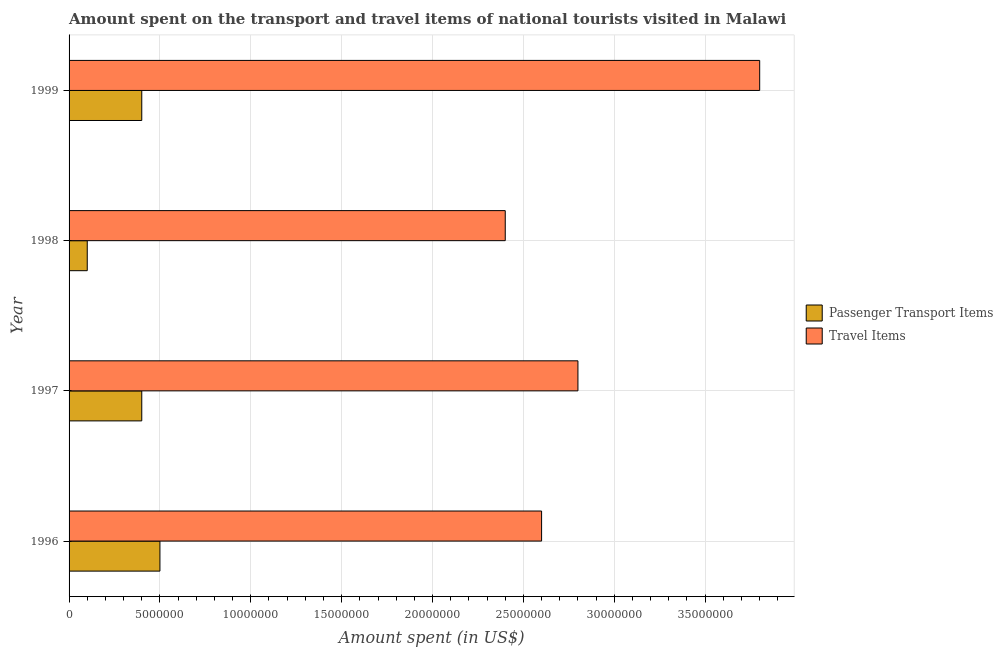Are the number of bars per tick equal to the number of legend labels?
Give a very brief answer. Yes. Are the number of bars on each tick of the Y-axis equal?
Give a very brief answer. Yes. How many bars are there on the 1st tick from the top?
Offer a very short reply. 2. How many bars are there on the 4th tick from the bottom?
Provide a succinct answer. 2. What is the label of the 4th group of bars from the top?
Provide a succinct answer. 1996. In how many cases, is the number of bars for a given year not equal to the number of legend labels?
Ensure brevity in your answer.  0. What is the amount spent on passenger transport items in 1998?
Your response must be concise. 1.00e+06. Across all years, what is the maximum amount spent in travel items?
Provide a short and direct response. 3.80e+07. Across all years, what is the minimum amount spent in travel items?
Make the answer very short. 2.40e+07. What is the total amount spent on passenger transport items in the graph?
Offer a terse response. 1.40e+07. What is the difference between the amount spent on passenger transport items in 1996 and that in 1999?
Offer a very short reply. 1.00e+06. What is the difference between the amount spent on passenger transport items in 1999 and the amount spent in travel items in 1996?
Make the answer very short. -2.20e+07. What is the average amount spent in travel items per year?
Provide a succinct answer. 2.90e+07. In the year 1999, what is the difference between the amount spent in travel items and amount spent on passenger transport items?
Provide a short and direct response. 3.40e+07. In how many years, is the amount spent in travel items greater than 31000000 US$?
Give a very brief answer. 1. What is the ratio of the amount spent in travel items in 1996 to that in 1998?
Offer a terse response. 1.08. Is the amount spent in travel items in 1996 less than that in 1998?
Provide a succinct answer. No. Is the difference between the amount spent in travel items in 1996 and 1998 greater than the difference between the amount spent on passenger transport items in 1996 and 1998?
Ensure brevity in your answer.  No. What is the difference between the highest and the second highest amount spent on passenger transport items?
Provide a succinct answer. 1.00e+06. What is the difference between the highest and the lowest amount spent in travel items?
Provide a short and direct response. 1.40e+07. In how many years, is the amount spent in travel items greater than the average amount spent in travel items taken over all years?
Ensure brevity in your answer.  1. Is the sum of the amount spent in travel items in 1998 and 1999 greater than the maximum amount spent on passenger transport items across all years?
Ensure brevity in your answer.  Yes. What does the 1st bar from the top in 1996 represents?
Give a very brief answer. Travel Items. What does the 1st bar from the bottom in 1997 represents?
Give a very brief answer. Passenger Transport Items. Are all the bars in the graph horizontal?
Make the answer very short. Yes. How many years are there in the graph?
Your answer should be compact. 4. Are the values on the major ticks of X-axis written in scientific E-notation?
Offer a very short reply. No. Does the graph contain any zero values?
Give a very brief answer. No. What is the title of the graph?
Your answer should be very brief. Amount spent on the transport and travel items of national tourists visited in Malawi. Does "Males" appear as one of the legend labels in the graph?
Offer a very short reply. No. What is the label or title of the X-axis?
Ensure brevity in your answer.  Amount spent (in US$). What is the Amount spent (in US$) of Passenger Transport Items in 1996?
Offer a terse response. 5.00e+06. What is the Amount spent (in US$) of Travel Items in 1996?
Your answer should be very brief. 2.60e+07. What is the Amount spent (in US$) of Travel Items in 1997?
Your answer should be compact. 2.80e+07. What is the Amount spent (in US$) in Travel Items in 1998?
Offer a terse response. 2.40e+07. What is the Amount spent (in US$) in Passenger Transport Items in 1999?
Ensure brevity in your answer.  4.00e+06. What is the Amount spent (in US$) in Travel Items in 1999?
Your response must be concise. 3.80e+07. Across all years, what is the maximum Amount spent (in US$) in Passenger Transport Items?
Your answer should be very brief. 5.00e+06. Across all years, what is the maximum Amount spent (in US$) in Travel Items?
Keep it short and to the point. 3.80e+07. Across all years, what is the minimum Amount spent (in US$) of Passenger Transport Items?
Provide a short and direct response. 1.00e+06. Across all years, what is the minimum Amount spent (in US$) in Travel Items?
Keep it short and to the point. 2.40e+07. What is the total Amount spent (in US$) in Passenger Transport Items in the graph?
Offer a very short reply. 1.40e+07. What is the total Amount spent (in US$) in Travel Items in the graph?
Keep it short and to the point. 1.16e+08. What is the difference between the Amount spent (in US$) in Passenger Transport Items in 1996 and that in 1999?
Your response must be concise. 1.00e+06. What is the difference between the Amount spent (in US$) in Travel Items in 1996 and that in 1999?
Provide a short and direct response. -1.20e+07. What is the difference between the Amount spent (in US$) in Passenger Transport Items in 1997 and that in 1998?
Your response must be concise. 3.00e+06. What is the difference between the Amount spent (in US$) in Travel Items in 1997 and that in 1998?
Ensure brevity in your answer.  4.00e+06. What is the difference between the Amount spent (in US$) in Passenger Transport Items in 1997 and that in 1999?
Offer a very short reply. 0. What is the difference between the Amount spent (in US$) of Travel Items in 1997 and that in 1999?
Your answer should be very brief. -1.00e+07. What is the difference between the Amount spent (in US$) of Passenger Transport Items in 1998 and that in 1999?
Your answer should be very brief. -3.00e+06. What is the difference between the Amount spent (in US$) in Travel Items in 1998 and that in 1999?
Ensure brevity in your answer.  -1.40e+07. What is the difference between the Amount spent (in US$) of Passenger Transport Items in 1996 and the Amount spent (in US$) of Travel Items in 1997?
Ensure brevity in your answer.  -2.30e+07. What is the difference between the Amount spent (in US$) in Passenger Transport Items in 1996 and the Amount spent (in US$) in Travel Items in 1998?
Provide a short and direct response. -1.90e+07. What is the difference between the Amount spent (in US$) in Passenger Transport Items in 1996 and the Amount spent (in US$) in Travel Items in 1999?
Make the answer very short. -3.30e+07. What is the difference between the Amount spent (in US$) in Passenger Transport Items in 1997 and the Amount spent (in US$) in Travel Items in 1998?
Provide a succinct answer. -2.00e+07. What is the difference between the Amount spent (in US$) in Passenger Transport Items in 1997 and the Amount spent (in US$) in Travel Items in 1999?
Make the answer very short. -3.40e+07. What is the difference between the Amount spent (in US$) of Passenger Transport Items in 1998 and the Amount spent (in US$) of Travel Items in 1999?
Ensure brevity in your answer.  -3.70e+07. What is the average Amount spent (in US$) in Passenger Transport Items per year?
Offer a very short reply. 3.50e+06. What is the average Amount spent (in US$) in Travel Items per year?
Ensure brevity in your answer.  2.90e+07. In the year 1996, what is the difference between the Amount spent (in US$) of Passenger Transport Items and Amount spent (in US$) of Travel Items?
Your response must be concise. -2.10e+07. In the year 1997, what is the difference between the Amount spent (in US$) of Passenger Transport Items and Amount spent (in US$) of Travel Items?
Your answer should be very brief. -2.40e+07. In the year 1998, what is the difference between the Amount spent (in US$) in Passenger Transport Items and Amount spent (in US$) in Travel Items?
Ensure brevity in your answer.  -2.30e+07. In the year 1999, what is the difference between the Amount spent (in US$) of Passenger Transport Items and Amount spent (in US$) of Travel Items?
Offer a very short reply. -3.40e+07. What is the ratio of the Amount spent (in US$) in Passenger Transport Items in 1996 to that in 1999?
Offer a terse response. 1.25. What is the ratio of the Amount spent (in US$) in Travel Items in 1996 to that in 1999?
Make the answer very short. 0.68. What is the ratio of the Amount spent (in US$) of Travel Items in 1997 to that in 1999?
Make the answer very short. 0.74. What is the ratio of the Amount spent (in US$) of Passenger Transport Items in 1998 to that in 1999?
Your answer should be very brief. 0.25. What is the ratio of the Amount spent (in US$) in Travel Items in 1998 to that in 1999?
Make the answer very short. 0.63. What is the difference between the highest and the lowest Amount spent (in US$) of Travel Items?
Provide a succinct answer. 1.40e+07. 